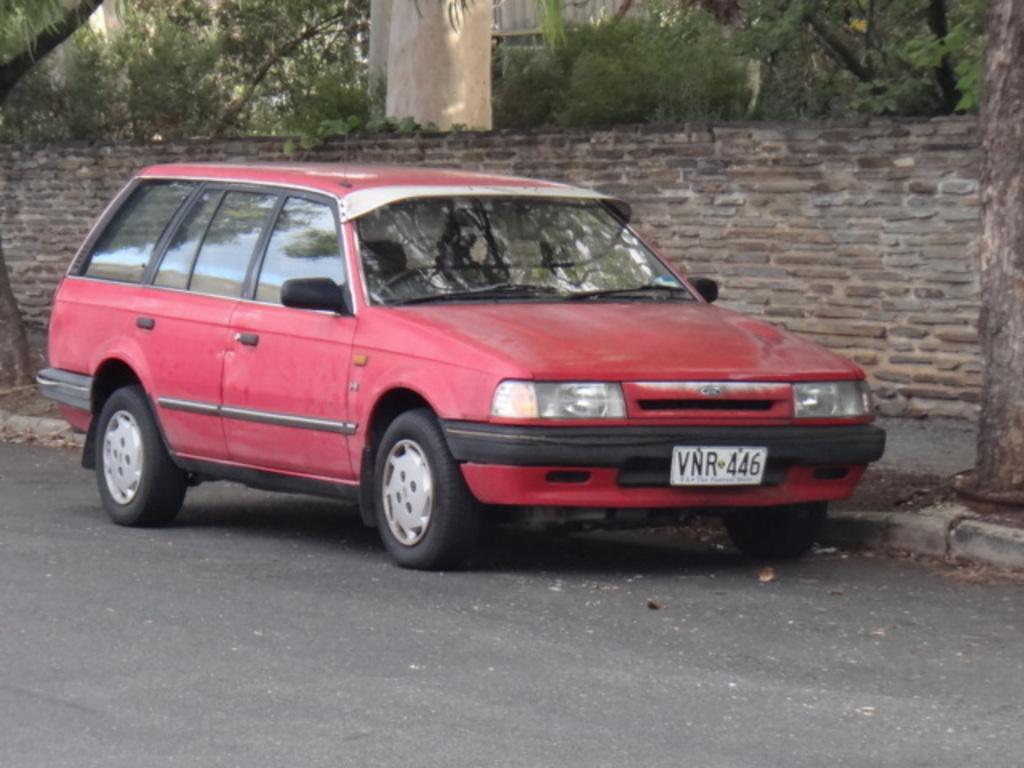What color is the car in the image? The car in the image is red. Where is the car located in the image? The car is on the road in the image. What can be seen in the background of the image? There is a wall and trees visible in the background of the image. Are there any slaves visible in the image? There are no slaves present in the image. Is there a fight happening in the image? There is no fight depicted in the image. 